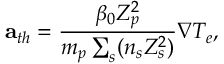<formula> <loc_0><loc_0><loc_500><loc_500>{ a } _ { t h } = \frac { \beta _ { 0 } Z _ { p } ^ { 2 } } { m _ { p } \sum _ { s } ( n _ { s } Z _ { s } ^ { 2 } ) } \nabla T _ { e } ,</formula> 